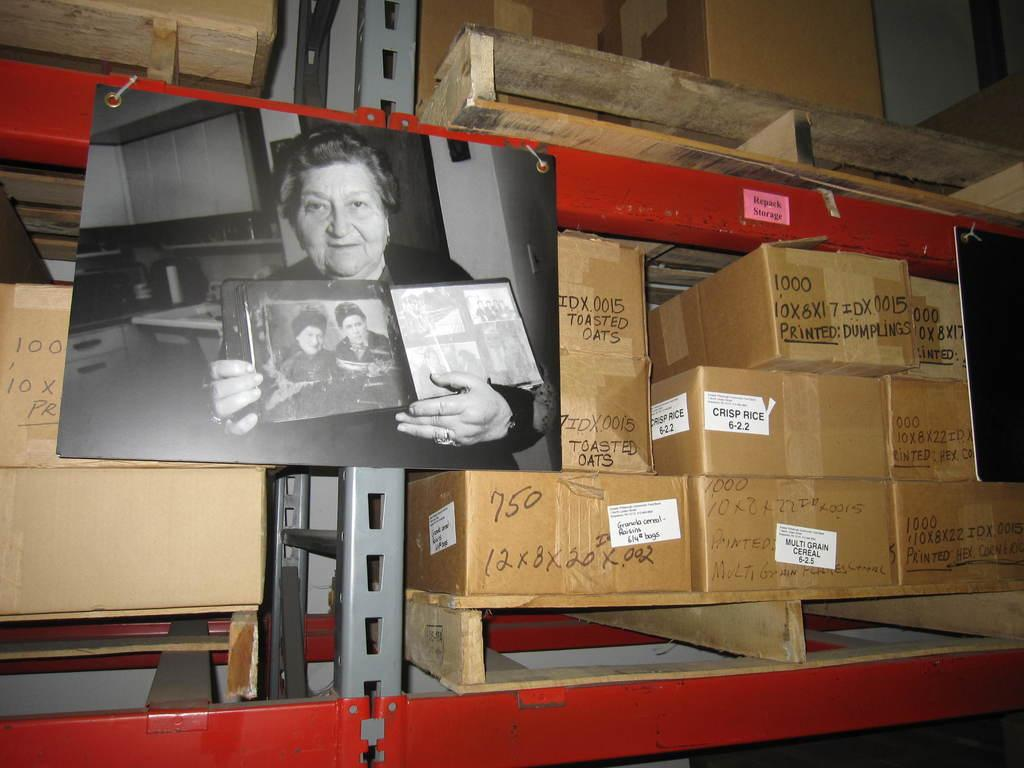<image>
Render a clear and concise summary of the photo. Several cardboard box's are stacked on a shelf  with one reading "printed: dumplings" 